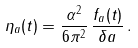Convert formula to latex. <formula><loc_0><loc_0><loc_500><loc_500>\eta _ { a } ( t ) = \frac { \alpha ^ { 2 } } { 6 \pi ^ { 2 } } \, \frac { f _ { a } ( t ) } { \delta a } \, .</formula> 